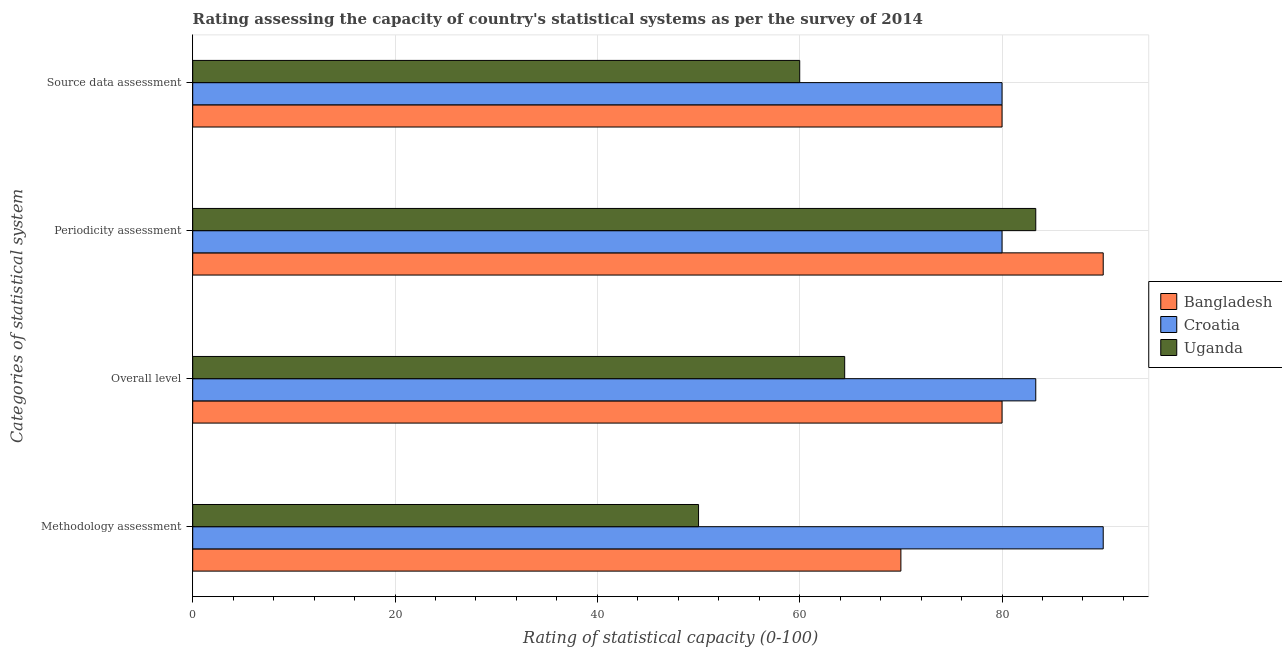How many groups of bars are there?
Keep it short and to the point. 4. How many bars are there on the 3rd tick from the top?
Keep it short and to the point. 3. What is the label of the 1st group of bars from the top?
Offer a terse response. Source data assessment. Across all countries, what is the maximum overall level rating?
Keep it short and to the point. 83.33. Across all countries, what is the minimum methodology assessment rating?
Ensure brevity in your answer.  50. In which country was the overall level rating maximum?
Your response must be concise. Croatia. In which country was the source data assessment rating minimum?
Make the answer very short. Uganda. What is the total source data assessment rating in the graph?
Offer a very short reply. 220. What is the difference between the overall level rating in Uganda and that in Bangladesh?
Provide a succinct answer. -15.56. What is the average overall level rating per country?
Provide a succinct answer. 75.93. What is the difference between the periodicity assessment rating and methodology assessment rating in Bangladesh?
Offer a terse response. 20. What is the ratio of the source data assessment rating in Croatia to that in Uganda?
Keep it short and to the point. 1.33. Is the overall level rating in Bangladesh less than that in Uganda?
Your response must be concise. No. Is the difference between the methodology assessment rating in Uganda and Croatia greater than the difference between the overall level rating in Uganda and Croatia?
Make the answer very short. No. What is the difference between the highest and the lowest source data assessment rating?
Provide a succinct answer. 20. What does the 1st bar from the top in Periodicity assessment represents?
Your response must be concise. Uganda. What does the 3rd bar from the bottom in Source data assessment represents?
Provide a short and direct response. Uganda. Is it the case that in every country, the sum of the methodology assessment rating and overall level rating is greater than the periodicity assessment rating?
Make the answer very short. Yes. Are the values on the major ticks of X-axis written in scientific E-notation?
Your answer should be very brief. No. Where does the legend appear in the graph?
Keep it short and to the point. Center right. What is the title of the graph?
Make the answer very short. Rating assessing the capacity of country's statistical systems as per the survey of 2014 . What is the label or title of the X-axis?
Your answer should be very brief. Rating of statistical capacity (0-100). What is the label or title of the Y-axis?
Your answer should be compact. Categories of statistical system. What is the Rating of statistical capacity (0-100) of Bangladesh in Methodology assessment?
Provide a succinct answer. 70. What is the Rating of statistical capacity (0-100) of Croatia in Methodology assessment?
Your answer should be compact. 90. What is the Rating of statistical capacity (0-100) in Uganda in Methodology assessment?
Provide a succinct answer. 50. What is the Rating of statistical capacity (0-100) in Bangladesh in Overall level?
Offer a very short reply. 80. What is the Rating of statistical capacity (0-100) of Croatia in Overall level?
Provide a short and direct response. 83.33. What is the Rating of statistical capacity (0-100) of Uganda in Overall level?
Your answer should be compact. 64.44. What is the Rating of statistical capacity (0-100) of Bangladesh in Periodicity assessment?
Provide a succinct answer. 90. What is the Rating of statistical capacity (0-100) in Uganda in Periodicity assessment?
Ensure brevity in your answer.  83.33. What is the Rating of statistical capacity (0-100) of Bangladesh in Source data assessment?
Offer a very short reply. 80. What is the Rating of statistical capacity (0-100) in Croatia in Source data assessment?
Your response must be concise. 80. Across all Categories of statistical system, what is the maximum Rating of statistical capacity (0-100) of Croatia?
Ensure brevity in your answer.  90. Across all Categories of statistical system, what is the maximum Rating of statistical capacity (0-100) in Uganda?
Make the answer very short. 83.33. Across all Categories of statistical system, what is the minimum Rating of statistical capacity (0-100) in Uganda?
Your answer should be very brief. 50. What is the total Rating of statistical capacity (0-100) in Bangladesh in the graph?
Give a very brief answer. 320. What is the total Rating of statistical capacity (0-100) in Croatia in the graph?
Ensure brevity in your answer.  333.33. What is the total Rating of statistical capacity (0-100) of Uganda in the graph?
Your response must be concise. 257.78. What is the difference between the Rating of statistical capacity (0-100) in Croatia in Methodology assessment and that in Overall level?
Ensure brevity in your answer.  6.67. What is the difference between the Rating of statistical capacity (0-100) in Uganda in Methodology assessment and that in Overall level?
Provide a succinct answer. -14.44. What is the difference between the Rating of statistical capacity (0-100) in Bangladesh in Methodology assessment and that in Periodicity assessment?
Your response must be concise. -20. What is the difference between the Rating of statistical capacity (0-100) of Uganda in Methodology assessment and that in Periodicity assessment?
Make the answer very short. -33.33. What is the difference between the Rating of statistical capacity (0-100) in Bangladesh in Methodology assessment and that in Source data assessment?
Your answer should be very brief. -10. What is the difference between the Rating of statistical capacity (0-100) of Croatia in Methodology assessment and that in Source data assessment?
Make the answer very short. 10. What is the difference between the Rating of statistical capacity (0-100) of Uganda in Overall level and that in Periodicity assessment?
Offer a terse response. -18.89. What is the difference between the Rating of statistical capacity (0-100) of Croatia in Overall level and that in Source data assessment?
Make the answer very short. 3.33. What is the difference between the Rating of statistical capacity (0-100) in Uganda in Overall level and that in Source data assessment?
Make the answer very short. 4.44. What is the difference between the Rating of statistical capacity (0-100) in Bangladesh in Periodicity assessment and that in Source data assessment?
Make the answer very short. 10. What is the difference between the Rating of statistical capacity (0-100) in Uganda in Periodicity assessment and that in Source data assessment?
Provide a succinct answer. 23.33. What is the difference between the Rating of statistical capacity (0-100) of Bangladesh in Methodology assessment and the Rating of statistical capacity (0-100) of Croatia in Overall level?
Keep it short and to the point. -13.33. What is the difference between the Rating of statistical capacity (0-100) in Bangladesh in Methodology assessment and the Rating of statistical capacity (0-100) in Uganda in Overall level?
Your answer should be very brief. 5.56. What is the difference between the Rating of statistical capacity (0-100) in Croatia in Methodology assessment and the Rating of statistical capacity (0-100) in Uganda in Overall level?
Your response must be concise. 25.56. What is the difference between the Rating of statistical capacity (0-100) in Bangladesh in Methodology assessment and the Rating of statistical capacity (0-100) in Uganda in Periodicity assessment?
Your answer should be compact. -13.33. What is the difference between the Rating of statistical capacity (0-100) of Croatia in Methodology assessment and the Rating of statistical capacity (0-100) of Uganda in Source data assessment?
Give a very brief answer. 30. What is the difference between the Rating of statistical capacity (0-100) of Bangladesh in Overall level and the Rating of statistical capacity (0-100) of Croatia in Periodicity assessment?
Make the answer very short. 0. What is the difference between the Rating of statistical capacity (0-100) of Bangladesh in Overall level and the Rating of statistical capacity (0-100) of Uganda in Periodicity assessment?
Your answer should be compact. -3.33. What is the difference between the Rating of statistical capacity (0-100) of Croatia in Overall level and the Rating of statistical capacity (0-100) of Uganda in Source data assessment?
Your answer should be very brief. 23.33. What is the difference between the Rating of statistical capacity (0-100) of Bangladesh in Periodicity assessment and the Rating of statistical capacity (0-100) of Uganda in Source data assessment?
Give a very brief answer. 30. What is the average Rating of statistical capacity (0-100) of Bangladesh per Categories of statistical system?
Provide a succinct answer. 80. What is the average Rating of statistical capacity (0-100) in Croatia per Categories of statistical system?
Give a very brief answer. 83.33. What is the average Rating of statistical capacity (0-100) of Uganda per Categories of statistical system?
Your answer should be compact. 64.44. What is the difference between the Rating of statistical capacity (0-100) in Bangladesh and Rating of statistical capacity (0-100) in Croatia in Methodology assessment?
Offer a terse response. -20. What is the difference between the Rating of statistical capacity (0-100) in Croatia and Rating of statistical capacity (0-100) in Uganda in Methodology assessment?
Your answer should be very brief. 40. What is the difference between the Rating of statistical capacity (0-100) in Bangladesh and Rating of statistical capacity (0-100) in Croatia in Overall level?
Make the answer very short. -3.33. What is the difference between the Rating of statistical capacity (0-100) in Bangladesh and Rating of statistical capacity (0-100) in Uganda in Overall level?
Your answer should be very brief. 15.56. What is the difference between the Rating of statistical capacity (0-100) of Croatia and Rating of statistical capacity (0-100) of Uganda in Overall level?
Make the answer very short. 18.89. What is the difference between the Rating of statistical capacity (0-100) of Bangladesh and Rating of statistical capacity (0-100) of Croatia in Source data assessment?
Your response must be concise. 0. What is the difference between the Rating of statistical capacity (0-100) in Bangladesh and Rating of statistical capacity (0-100) in Uganda in Source data assessment?
Your answer should be very brief. 20. What is the ratio of the Rating of statistical capacity (0-100) of Uganda in Methodology assessment to that in Overall level?
Your answer should be very brief. 0.78. What is the ratio of the Rating of statistical capacity (0-100) of Uganda in Methodology assessment to that in Periodicity assessment?
Your response must be concise. 0.6. What is the ratio of the Rating of statistical capacity (0-100) of Bangladesh in Methodology assessment to that in Source data assessment?
Offer a very short reply. 0.88. What is the ratio of the Rating of statistical capacity (0-100) in Bangladesh in Overall level to that in Periodicity assessment?
Offer a very short reply. 0.89. What is the ratio of the Rating of statistical capacity (0-100) of Croatia in Overall level to that in Periodicity assessment?
Provide a short and direct response. 1.04. What is the ratio of the Rating of statistical capacity (0-100) of Uganda in Overall level to that in Periodicity assessment?
Your answer should be very brief. 0.77. What is the ratio of the Rating of statistical capacity (0-100) of Croatia in Overall level to that in Source data assessment?
Offer a very short reply. 1.04. What is the ratio of the Rating of statistical capacity (0-100) of Uganda in Overall level to that in Source data assessment?
Offer a very short reply. 1.07. What is the ratio of the Rating of statistical capacity (0-100) of Bangladesh in Periodicity assessment to that in Source data assessment?
Provide a short and direct response. 1.12. What is the ratio of the Rating of statistical capacity (0-100) of Uganda in Periodicity assessment to that in Source data assessment?
Your response must be concise. 1.39. What is the difference between the highest and the second highest Rating of statistical capacity (0-100) in Bangladesh?
Ensure brevity in your answer.  10. What is the difference between the highest and the second highest Rating of statistical capacity (0-100) of Uganda?
Provide a succinct answer. 18.89. What is the difference between the highest and the lowest Rating of statistical capacity (0-100) in Croatia?
Your response must be concise. 10. What is the difference between the highest and the lowest Rating of statistical capacity (0-100) of Uganda?
Provide a succinct answer. 33.33. 